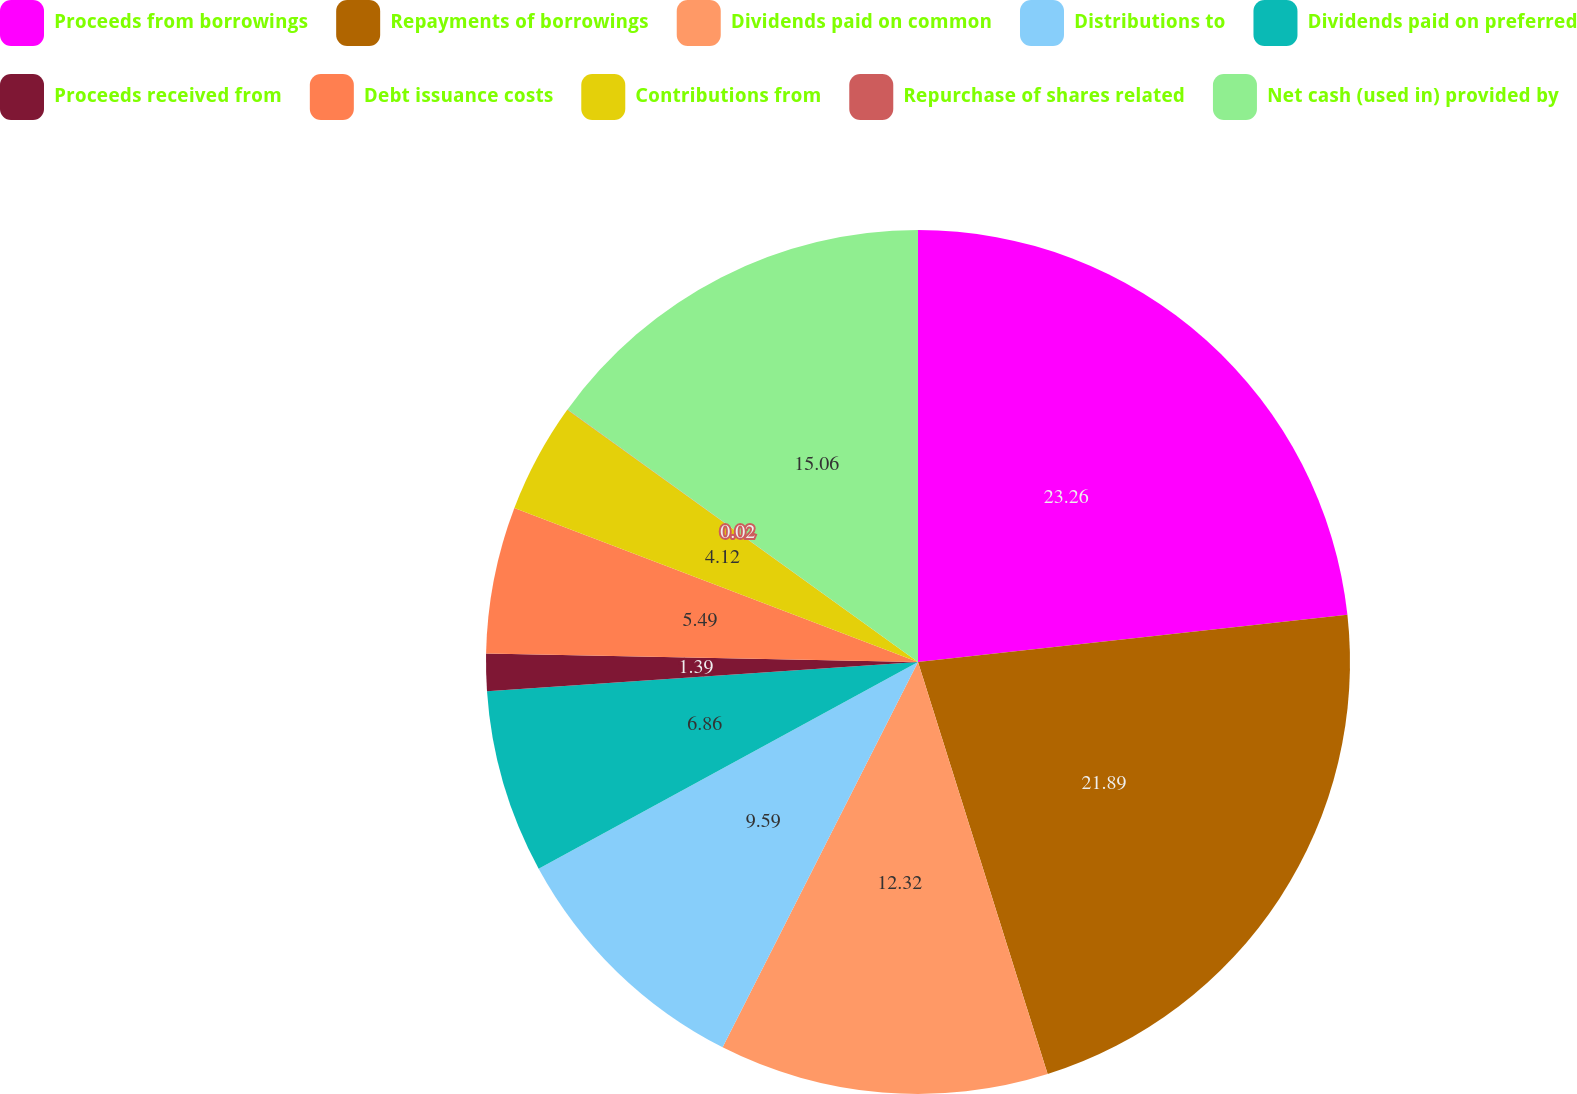Convert chart. <chart><loc_0><loc_0><loc_500><loc_500><pie_chart><fcel>Proceeds from borrowings<fcel>Repayments of borrowings<fcel>Dividends paid on common<fcel>Distributions to<fcel>Dividends paid on preferred<fcel>Proceeds received from<fcel>Debt issuance costs<fcel>Contributions from<fcel>Repurchase of shares related<fcel>Net cash (used in) provided by<nl><fcel>23.26%<fcel>21.89%<fcel>12.32%<fcel>9.59%<fcel>6.86%<fcel>1.39%<fcel>5.49%<fcel>4.12%<fcel>0.02%<fcel>15.06%<nl></chart> 